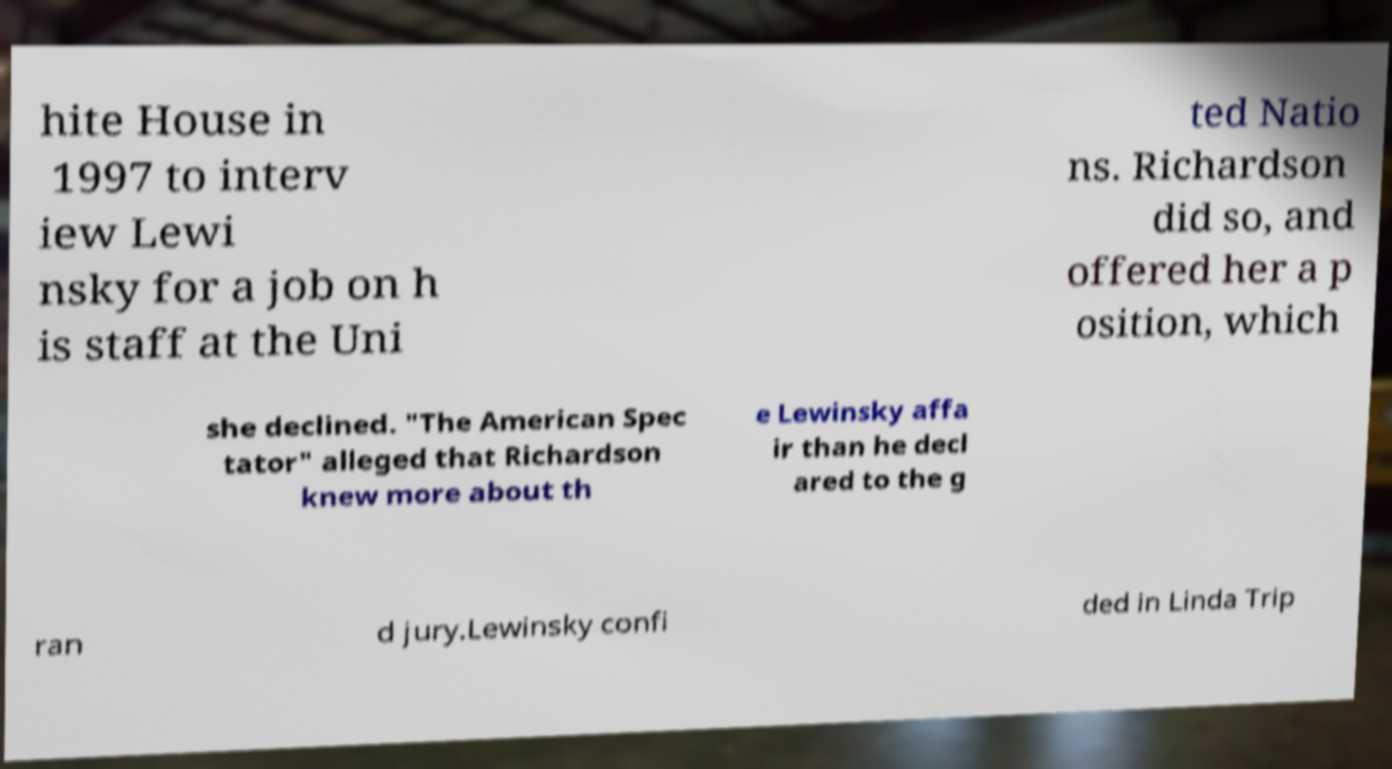Could you extract and type out the text from this image? hite House in 1997 to interv iew Lewi nsky for a job on h is staff at the Uni ted Natio ns. Richardson did so, and offered her a p osition, which she declined. "The American Spec tator" alleged that Richardson knew more about th e Lewinsky affa ir than he decl ared to the g ran d jury.Lewinsky confi ded in Linda Trip 